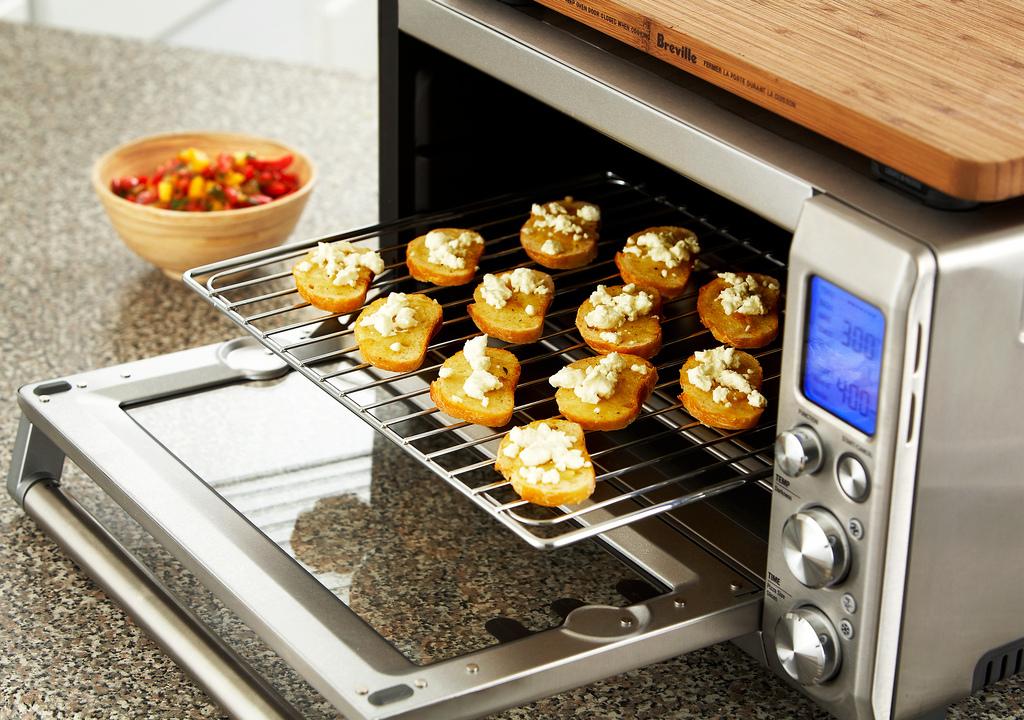What is the over set on?
Your response must be concise. 300. What is the name on the cutting board?
Your answer should be very brief. Breville. 